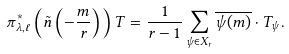<formula> <loc_0><loc_0><loc_500><loc_500>\pi ^ { * } _ { \lambda , \ell } \left ( \tilde { n } \left ( - \frac { m } { r } \right ) \right ) T = \frac { 1 } { r - 1 } \sum _ { \psi \in X _ { r } } \overline { \psi ( m ) } \cdot T _ { \psi } .</formula> 